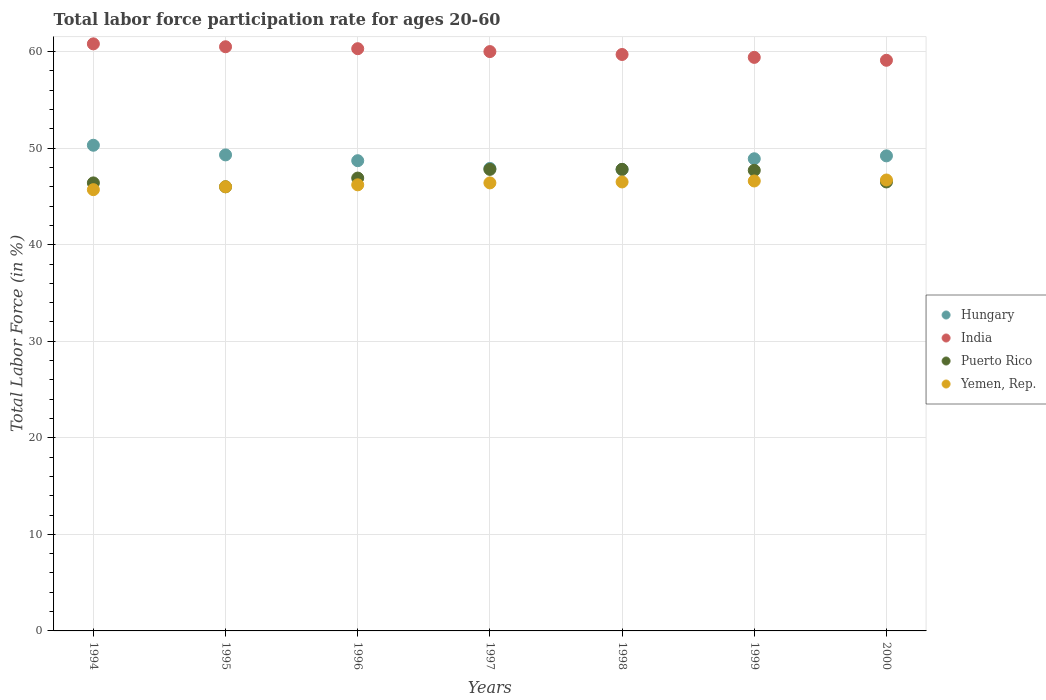Is the number of dotlines equal to the number of legend labels?
Your answer should be compact. Yes. What is the labor force participation rate in Yemen, Rep. in 1997?
Make the answer very short. 46.4. Across all years, what is the maximum labor force participation rate in India?
Keep it short and to the point. 60.8. Across all years, what is the minimum labor force participation rate in Yemen, Rep.?
Offer a terse response. 45.7. What is the total labor force participation rate in Puerto Rico in the graph?
Your answer should be very brief. 329.1. What is the difference between the labor force participation rate in Hungary in 1996 and that in 1998?
Offer a very short reply. 0.9. What is the difference between the labor force participation rate in Puerto Rico in 1998 and the labor force participation rate in Yemen, Rep. in 1994?
Provide a succinct answer. 2.1. What is the average labor force participation rate in Yemen, Rep. per year?
Provide a succinct answer. 46.3. In the year 1999, what is the difference between the labor force participation rate in India and labor force participation rate in Yemen, Rep.?
Ensure brevity in your answer.  12.8. In how many years, is the labor force participation rate in Puerto Rico greater than 46 %?
Your answer should be very brief. 6. What is the ratio of the labor force participation rate in Yemen, Rep. in 1996 to that in 2000?
Your answer should be compact. 0.99. What is the difference between the highest and the second highest labor force participation rate in India?
Offer a terse response. 0.3. What is the difference between the highest and the lowest labor force participation rate in India?
Ensure brevity in your answer.  1.7. Is the sum of the labor force participation rate in Hungary in 1995 and 1997 greater than the maximum labor force participation rate in India across all years?
Ensure brevity in your answer.  Yes. Is it the case that in every year, the sum of the labor force participation rate in Yemen, Rep. and labor force participation rate in India  is greater than the sum of labor force participation rate in Hungary and labor force participation rate in Puerto Rico?
Provide a short and direct response. Yes. Is it the case that in every year, the sum of the labor force participation rate in India and labor force participation rate in Yemen, Rep.  is greater than the labor force participation rate in Hungary?
Give a very brief answer. Yes. Does the labor force participation rate in India monotonically increase over the years?
Offer a terse response. No. Is the labor force participation rate in Puerto Rico strictly less than the labor force participation rate in Yemen, Rep. over the years?
Offer a very short reply. No. What is the difference between two consecutive major ticks on the Y-axis?
Offer a terse response. 10. Does the graph contain any zero values?
Offer a terse response. No. Does the graph contain grids?
Your answer should be very brief. Yes. What is the title of the graph?
Offer a terse response. Total labor force participation rate for ages 20-60. Does "Barbados" appear as one of the legend labels in the graph?
Offer a very short reply. No. What is the label or title of the X-axis?
Offer a very short reply. Years. What is the Total Labor Force (in %) in Hungary in 1994?
Ensure brevity in your answer.  50.3. What is the Total Labor Force (in %) of India in 1994?
Give a very brief answer. 60.8. What is the Total Labor Force (in %) in Puerto Rico in 1994?
Keep it short and to the point. 46.4. What is the Total Labor Force (in %) in Yemen, Rep. in 1994?
Keep it short and to the point. 45.7. What is the Total Labor Force (in %) of Hungary in 1995?
Your answer should be compact. 49.3. What is the Total Labor Force (in %) of India in 1995?
Your answer should be compact. 60.5. What is the Total Labor Force (in %) of Yemen, Rep. in 1995?
Provide a short and direct response. 46. What is the Total Labor Force (in %) in Hungary in 1996?
Your answer should be compact. 48.7. What is the Total Labor Force (in %) of India in 1996?
Your response must be concise. 60.3. What is the Total Labor Force (in %) of Puerto Rico in 1996?
Offer a terse response. 46.9. What is the Total Labor Force (in %) in Yemen, Rep. in 1996?
Your answer should be very brief. 46.2. What is the Total Labor Force (in %) of Hungary in 1997?
Provide a succinct answer. 47.9. What is the Total Labor Force (in %) of India in 1997?
Your response must be concise. 60. What is the Total Labor Force (in %) in Puerto Rico in 1997?
Offer a terse response. 47.8. What is the Total Labor Force (in %) in Yemen, Rep. in 1997?
Provide a succinct answer. 46.4. What is the Total Labor Force (in %) in Hungary in 1998?
Your answer should be compact. 47.8. What is the Total Labor Force (in %) in India in 1998?
Make the answer very short. 59.7. What is the Total Labor Force (in %) of Puerto Rico in 1998?
Make the answer very short. 47.8. What is the Total Labor Force (in %) of Yemen, Rep. in 1998?
Make the answer very short. 46.5. What is the Total Labor Force (in %) of Hungary in 1999?
Offer a very short reply. 48.9. What is the Total Labor Force (in %) of India in 1999?
Keep it short and to the point. 59.4. What is the Total Labor Force (in %) of Puerto Rico in 1999?
Give a very brief answer. 47.7. What is the Total Labor Force (in %) of Yemen, Rep. in 1999?
Your answer should be compact. 46.6. What is the Total Labor Force (in %) in Hungary in 2000?
Your answer should be compact. 49.2. What is the Total Labor Force (in %) of India in 2000?
Provide a short and direct response. 59.1. What is the Total Labor Force (in %) in Puerto Rico in 2000?
Ensure brevity in your answer.  46.5. What is the Total Labor Force (in %) of Yemen, Rep. in 2000?
Your answer should be very brief. 46.7. Across all years, what is the maximum Total Labor Force (in %) of Hungary?
Ensure brevity in your answer.  50.3. Across all years, what is the maximum Total Labor Force (in %) in India?
Your response must be concise. 60.8. Across all years, what is the maximum Total Labor Force (in %) of Puerto Rico?
Give a very brief answer. 47.8. Across all years, what is the maximum Total Labor Force (in %) in Yemen, Rep.?
Ensure brevity in your answer.  46.7. Across all years, what is the minimum Total Labor Force (in %) in Hungary?
Offer a very short reply. 47.8. Across all years, what is the minimum Total Labor Force (in %) of India?
Offer a terse response. 59.1. Across all years, what is the minimum Total Labor Force (in %) of Yemen, Rep.?
Give a very brief answer. 45.7. What is the total Total Labor Force (in %) of Hungary in the graph?
Offer a terse response. 342.1. What is the total Total Labor Force (in %) in India in the graph?
Your response must be concise. 419.8. What is the total Total Labor Force (in %) of Puerto Rico in the graph?
Provide a succinct answer. 329.1. What is the total Total Labor Force (in %) in Yemen, Rep. in the graph?
Your answer should be compact. 324.1. What is the difference between the Total Labor Force (in %) in Puerto Rico in 1994 and that in 1996?
Ensure brevity in your answer.  -0.5. What is the difference between the Total Labor Force (in %) of Yemen, Rep. in 1994 and that in 1996?
Your response must be concise. -0.5. What is the difference between the Total Labor Force (in %) of India in 1994 and that in 1997?
Ensure brevity in your answer.  0.8. What is the difference between the Total Labor Force (in %) of India in 1994 and that in 1998?
Your response must be concise. 1.1. What is the difference between the Total Labor Force (in %) of Puerto Rico in 1994 and that in 1999?
Ensure brevity in your answer.  -1.3. What is the difference between the Total Labor Force (in %) in Hungary in 1994 and that in 2000?
Offer a very short reply. 1.1. What is the difference between the Total Labor Force (in %) of India in 1994 and that in 2000?
Give a very brief answer. 1.7. What is the difference between the Total Labor Force (in %) in Yemen, Rep. in 1994 and that in 2000?
Your answer should be very brief. -1. What is the difference between the Total Labor Force (in %) in Puerto Rico in 1995 and that in 1996?
Offer a very short reply. -0.9. What is the difference between the Total Labor Force (in %) of Yemen, Rep. in 1995 and that in 1996?
Provide a succinct answer. -0.2. What is the difference between the Total Labor Force (in %) in India in 1995 and that in 1997?
Give a very brief answer. 0.5. What is the difference between the Total Labor Force (in %) of Puerto Rico in 1995 and that in 1997?
Ensure brevity in your answer.  -1.8. What is the difference between the Total Labor Force (in %) in Puerto Rico in 1995 and that in 1998?
Make the answer very short. -1.8. What is the difference between the Total Labor Force (in %) of Puerto Rico in 1995 and that in 1999?
Your answer should be very brief. -1.7. What is the difference between the Total Labor Force (in %) in Yemen, Rep. in 1995 and that in 1999?
Give a very brief answer. -0.6. What is the difference between the Total Labor Force (in %) of Hungary in 1995 and that in 2000?
Give a very brief answer. 0.1. What is the difference between the Total Labor Force (in %) in India in 1995 and that in 2000?
Your response must be concise. 1.4. What is the difference between the Total Labor Force (in %) of Puerto Rico in 1995 and that in 2000?
Ensure brevity in your answer.  -0.5. What is the difference between the Total Labor Force (in %) in India in 1996 and that in 1997?
Ensure brevity in your answer.  0.3. What is the difference between the Total Labor Force (in %) of Puerto Rico in 1996 and that in 1997?
Offer a terse response. -0.9. What is the difference between the Total Labor Force (in %) of Yemen, Rep. in 1996 and that in 1997?
Provide a succinct answer. -0.2. What is the difference between the Total Labor Force (in %) in India in 1996 and that in 1998?
Your answer should be very brief. 0.6. What is the difference between the Total Labor Force (in %) in Puerto Rico in 1996 and that in 1998?
Provide a succinct answer. -0.9. What is the difference between the Total Labor Force (in %) of India in 1996 and that in 1999?
Provide a succinct answer. 0.9. What is the difference between the Total Labor Force (in %) of Yemen, Rep. in 1996 and that in 1999?
Provide a succinct answer. -0.4. What is the difference between the Total Labor Force (in %) in Hungary in 1997 and that in 1999?
Offer a very short reply. -1. What is the difference between the Total Labor Force (in %) in India in 1997 and that in 1999?
Your response must be concise. 0.6. What is the difference between the Total Labor Force (in %) in Yemen, Rep. in 1997 and that in 1999?
Your response must be concise. -0.2. What is the difference between the Total Labor Force (in %) of Hungary in 1997 and that in 2000?
Offer a terse response. -1.3. What is the difference between the Total Labor Force (in %) of Yemen, Rep. in 1997 and that in 2000?
Offer a very short reply. -0.3. What is the difference between the Total Labor Force (in %) in Hungary in 1998 and that in 1999?
Offer a very short reply. -1.1. What is the difference between the Total Labor Force (in %) of India in 1998 and that in 1999?
Your answer should be compact. 0.3. What is the difference between the Total Labor Force (in %) of Puerto Rico in 1998 and that in 1999?
Provide a succinct answer. 0.1. What is the difference between the Total Labor Force (in %) in Yemen, Rep. in 1998 and that in 1999?
Make the answer very short. -0.1. What is the difference between the Total Labor Force (in %) of India in 1998 and that in 2000?
Offer a terse response. 0.6. What is the difference between the Total Labor Force (in %) of Yemen, Rep. in 1998 and that in 2000?
Ensure brevity in your answer.  -0.2. What is the difference between the Total Labor Force (in %) in India in 1999 and that in 2000?
Ensure brevity in your answer.  0.3. What is the difference between the Total Labor Force (in %) in Puerto Rico in 1999 and that in 2000?
Your answer should be very brief. 1.2. What is the difference between the Total Labor Force (in %) in Yemen, Rep. in 1999 and that in 2000?
Your answer should be compact. -0.1. What is the difference between the Total Labor Force (in %) of Hungary in 1994 and the Total Labor Force (in %) of Yemen, Rep. in 1995?
Your answer should be very brief. 4.3. What is the difference between the Total Labor Force (in %) in India in 1994 and the Total Labor Force (in %) in Puerto Rico in 1995?
Keep it short and to the point. 14.8. What is the difference between the Total Labor Force (in %) of India in 1994 and the Total Labor Force (in %) of Yemen, Rep. in 1995?
Provide a short and direct response. 14.8. What is the difference between the Total Labor Force (in %) of Puerto Rico in 1994 and the Total Labor Force (in %) of Yemen, Rep. in 1995?
Provide a succinct answer. 0.4. What is the difference between the Total Labor Force (in %) in Hungary in 1994 and the Total Labor Force (in %) in India in 1996?
Offer a very short reply. -10. What is the difference between the Total Labor Force (in %) in Hungary in 1994 and the Total Labor Force (in %) in Puerto Rico in 1996?
Make the answer very short. 3.4. What is the difference between the Total Labor Force (in %) in Hungary in 1994 and the Total Labor Force (in %) in Yemen, Rep. in 1996?
Provide a succinct answer. 4.1. What is the difference between the Total Labor Force (in %) of Hungary in 1994 and the Total Labor Force (in %) of Puerto Rico in 1997?
Offer a very short reply. 2.5. What is the difference between the Total Labor Force (in %) of India in 1994 and the Total Labor Force (in %) of Puerto Rico in 1997?
Offer a very short reply. 13. What is the difference between the Total Labor Force (in %) in India in 1994 and the Total Labor Force (in %) in Yemen, Rep. in 1997?
Your response must be concise. 14.4. What is the difference between the Total Labor Force (in %) of Hungary in 1994 and the Total Labor Force (in %) of India in 1998?
Offer a very short reply. -9.4. What is the difference between the Total Labor Force (in %) of Hungary in 1994 and the Total Labor Force (in %) of Puerto Rico in 1998?
Keep it short and to the point. 2.5. What is the difference between the Total Labor Force (in %) of India in 1994 and the Total Labor Force (in %) of Yemen, Rep. in 1998?
Offer a very short reply. 14.3. What is the difference between the Total Labor Force (in %) of Hungary in 1994 and the Total Labor Force (in %) of Puerto Rico in 1999?
Your response must be concise. 2.6. What is the difference between the Total Labor Force (in %) of India in 1994 and the Total Labor Force (in %) of Puerto Rico in 1999?
Provide a succinct answer. 13.1. What is the difference between the Total Labor Force (in %) of India in 1994 and the Total Labor Force (in %) of Yemen, Rep. in 1999?
Ensure brevity in your answer.  14.2. What is the difference between the Total Labor Force (in %) of Puerto Rico in 1994 and the Total Labor Force (in %) of Yemen, Rep. in 1999?
Provide a short and direct response. -0.2. What is the difference between the Total Labor Force (in %) in Hungary in 1994 and the Total Labor Force (in %) in Puerto Rico in 2000?
Give a very brief answer. 3.8. What is the difference between the Total Labor Force (in %) in India in 1994 and the Total Labor Force (in %) in Yemen, Rep. in 2000?
Provide a succinct answer. 14.1. What is the difference between the Total Labor Force (in %) in Hungary in 1995 and the Total Labor Force (in %) in Puerto Rico in 1996?
Offer a terse response. 2.4. What is the difference between the Total Labor Force (in %) in Hungary in 1995 and the Total Labor Force (in %) in Yemen, Rep. in 1996?
Make the answer very short. 3.1. What is the difference between the Total Labor Force (in %) of India in 1995 and the Total Labor Force (in %) of Yemen, Rep. in 1996?
Give a very brief answer. 14.3. What is the difference between the Total Labor Force (in %) in India in 1995 and the Total Labor Force (in %) in Puerto Rico in 1997?
Give a very brief answer. 12.7. What is the difference between the Total Labor Force (in %) of India in 1995 and the Total Labor Force (in %) of Yemen, Rep. in 1997?
Give a very brief answer. 14.1. What is the difference between the Total Labor Force (in %) in Puerto Rico in 1995 and the Total Labor Force (in %) in Yemen, Rep. in 1997?
Provide a short and direct response. -0.4. What is the difference between the Total Labor Force (in %) of Hungary in 1995 and the Total Labor Force (in %) of Yemen, Rep. in 1998?
Your answer should be very brief. 2.8. What is the difference between the Total Labor Force (in %) of India in 1995 and the Total Labor Force (in %) of Yemen, Rep. in 1998?
Provide a succinct answer. 14. What is the difference between the Total Labor Force (in %) in Puerto Rico in 1995 and the Total Labor Force (in %) in Yemen, Rep. in 1998?
Your answer should be very brief. -0.5. What is the difference between the Total Labor Force (in %) of Hungary in 1995 and the Total Labor Force (in %) of India in 1999?
Provide a succinct answer. -10.1. What is the difference between the Total Labor Force (in %) of Hungary in 1995 and the Total Labor Force (in %) of Puerto Rico in 1999?
Your answer should be very brief. 1.6. What is the difference between the Total Labor Force (in %) of Hungary in 1995 and the Total Labor Force (in %) of Yemen, Rep. in 1999?
Give a very brief answer. 2.7. What is the difference between the Total Labor Force (in %) of Hungary in 1995 and the Total Labor Force (in %) of India in 2000?
Provide a succinct answer. -9.8. What is the difference between the Total Labor Force (in %) in Hungary in 1995 and the Total Labor Force (in %) in Puerto Rico in 2000?
Provide a succinct answer. 2.8. What is the difference between the Total Labor Force (in %) in Hungary in 1995 and the Total Labor Force (in %) in Yemen, Rep. in 2000?
Your answer should be very brief. 2.6. What is the difference between the Total Labor Force (in %) in Puerto Rico in 1995 and the Total Labor Force (in %) in Yemen, Rep. in 2000?
Offer a terse response. -0.7. What is the difference between the Total Labor Force (in %) of Hungary in 1996 and the Total Labor Force (in %) of Puerto Rico in 1997?
Provide a short and direct response. 0.9. What is the difference between the Total Labor Force (in %) of Hungary in 1996 and the Total Labor Force (in %) of Yemen, Rep. in 1997?
Your answer should be very brief. 2.3. What is the difference between the Total Labor Force (in %) in Hungary in 1996 and the Total Labor Force (in %) in Puerto Rico in 1998?
Provide a short and direct response. 0.9. What is the difference between the Total Labor Force (in %) in India in 1996 and the Total Labor Force (in %) in Puerto Rico in 1998?
Your response must be concise. 12.5. What is the difference between the Total Labor Force (in %) of Puerto Rico in 1996 and the Total Labor Force (in %) of Yemen, Rep. in 1998?
Your answer should be very brief. 0.4. What is the difference between the Total Labor Force (in %) of Hungary in 1996 and the Total Labor Force (in %) of India in 1999?
Provide a succinct answer. -10.7. What is the difference between the Total Labor Force (in %) of Hungary in 1996 and the Total Labor Force (in %) of Puerto Rico in 1999?
Keep it short and to the point. 1. What is the difference between the Total Labor Force (in %) in India in 1996 and the Total Labor Force (in %) in Yemen, Rep. in 1999?
Your answer should be compact. 13.7. What is the difference between the Total Labor Force (in %) in Hungary in 1996 and the Total Labor Force (in %) in Puerto Rico in 2000?
Your response must be concise. 2.2. What is the difference between the Total Labor Force (in %) in Hungary in 1996 and the Total Labor Force (in %) in Yemen, Rep. in 2000?
Your response must be concise. 2. What is the difference between the Total Labor Force (in %) of Hungary in 1997 and the Total Labor Force (in %) of India in 1999?
Offer a terse response. -11.5. What is the difference between the Total Labor Force (in %) of Hungary in 1997 and the Total Labor Force (in %) of Puerto Rico in 1999?
Offer a terse response. 0.2. What is the difference between the Total Labor Force (in %) of Hungary in 1997 and the Total Labor Force (in %) of Yemen, Rep. in 1999?
Give a very brief answer. 1.3. What is the difference between the Total Labor Force (in %) in India in 1997 and the Total Labor Force (in %) in Yemen, Rep. in 1999?
Offer a very short reply. 13.4. What is the difference between the Total Labor Force (in %) of Puerto Rico in 1997 and the Total Labor Force (in %) of Yemen, Rep. in 1999?
Provide a short and direct response. 1.2. What is the difference between the Total Labor Force (in %) in India in 1997 and the Total Labor Force (in %) in Puerto Rico in 2000?
Provide a short and direct response. 13.5. What is the difference between the Total Labor Force (in %) of Hungary in 1998 and the Total Labor Force (in %) of Yemen, Rep. in 1999?
Keep it short and to the point. 1.2. What is the difference between the Total Labor Force (in %) in Puerto Rico in 1998 and the Total Labor Force (in %) in Yemen, Rep. in 1999?
Make the answer very short. 1.2. What is the difference between the Total Labor Force (in %) in Hungary in 1998 and the Total Labor Force (in %) in India in 2000?
Offer a terse response. -11.3. What is the difference between the Total Labor Force (in %) in Hungary in 1998 and the Total Labor Force (in %) in Puerto Rico in 2000?
Your answer should be compact. 1.3. What is the difference between the Total Labor Force (in %) in Hungary in 1998 and the Total Labor Force (in %) in Yemen, Rep. in 2000?
Offer a terse response. 1.1. What is the difference between the Total Labor Force (in %) in India in 1998 and the Total Labor Force (in %) in Yemen, Rep. in 2000?
Give a very brief answer. 13. What is the difference between the Total Labor Force (in %) of Puerto Rico in 1998 and the Total Labor Force (in %) of Yemen, Rep. in 2000?
Keep it short and to the point. 1.1. What is the difference between the Total Labor Force (in %) in Hungary in 1999 and the Total Labor Force (in %) in Puerto Rico in 2000?
Offer a terse response. 2.4. What is the difference between the Total Labor Force (in %) in India in 1999 and the Total Labor Force (in %) in Puerto Rico in 2000?
Provide a short and direct response. 12.9. What is the average Total Labor Force (in %) of Hungary per year?
Give a very brief answer. 48.87. What is the average Total Labor Force (in %) in India per year?
Offer a terse response. 59.97. What is the average Total Labor Force (in %) of Puerto Rico per year?
Offer a very short reply. 47.01. What is the average Total Labor Force (in %) of Yemen, Rep. per year?
Offer a very short reply. 46.3. In the year 1994, what is the difference between the Total Labor Force (in %) in Hungary and Total Labor Force (in %) in Yemen, Rep.?
Keep it short and to the point. 4.6. In the year 1994, what is the difference between the Total Labor Force (in %) in India and Total Labor Force (in %) in Puerto Rico?
Provide a short and direct response. 14.4. In the year 1994, what is the difference between the Total Labor Force (in %) in Puerto Rico and Total Labor Force (in %) in Yemen, Rep.?
Your answer should be compact. 0.7. In the year 1995, what is the difference between the Total Labor Force (in %) in Hungary and Total Labor Force (in %) in India?
Your answer should be very brief. -11.2. In the year 1995, what is the difference between the Total Labor Force (in %) of Hungary and Total Labor Force (in %) of Yemen, Rep.?
Provide a short and direct response. 3.3. In the year 1995, what is the difference between the Total Labor Force (in %) in India and Total Labor Force (in %) in Yemen, Rep.?
Make the answer very short. 14.5. In the year 1995, what is the difference between the Total Labor Force (in %) in Puerto Rico and Total Labor Force (in %) in Yemen, Rep.?
Provide a short and direct response. 0. In the year 1996, what is the difference between the Total Labor Force (in %) of Hungary and Total Labor Force (in %) of Yemen, Rep.?
Make the answer very short. 2.5. In the year 1996, what is the difference between the Total Labor Force (in %) of Puerto Rico and Total Labor Force (in %) of Yemen, Rep.?
Give a very brief answer. 0.7. In the year 1997, what is the difference between the Total Labor Force (in %) in Hungary and Total Labor Force (in %) in Puerto Rico?
Provide a succinct answer. 0.1. In the year 1997, what is the difference between the Total Labor Force (in %) of Hungary and Total Labor Force (in %) of Yemen, Rep.?
Your answer should be compact. 1.5. In the year 1998, what is the difference between the Total Labor Force (in %) in Hungary and Total Labor Force (in %) in Puerto Rico?
Provide a short and direct response. 0. In the year 1998, what is the difference between the Total Labor Force (in %) of Hungary and Total Labor Force (in %) of Yemen, Rep.?
Provide a succinct answer. 1.3. In the year 1998, what is the difference between the Total Labor Force (in %) of India and Total Labor Force (in %) of Yemen, Rep.?
Keep it short and to the point. 13.2. In the year 1998, what is the difference between the Total Labor Force (in %) in Puerto Rico and Total Labor Force (in %) in Yemen, Rep.?
Make the answer very short. 1.3. In the year 1999, what is the difference between the Total Labor Force (in %) of Hungary and Total Labor Force (in %) of India?
Give a very brief answer. -10.5. In the year 1999, what is the difference between the Total Labor Force (in %) in Hungary and Total Labor Force (in %) in Yemen, Rep.?
Provide a succinct answer. 2.3. In the year 1999, what is the difference between the Total Labor Force (in %) in India and Total Labor Force (in %) in Puerto Rico?
Your answer should be compact. 11.7. In the year 2000, what is the difference between the Total Labor Force (in %) in Hungary and Total Labor Force (in %) in India?
Ensure brevity in your answer.  -9.9. In the year 2000, what is the difference between the Total Labor Force (in %) of Hungary and Total Labor Force (in %) of Puerto Rico?
Provide a succinct answer. 2.7. In the year 2000, what is the difference between the Total Labor Force (in %) of Hungary and Total Labor Force (in %) of Yemen, Rep.?
Offer a very short reply. 2.5. In the year 2000, what is the difference between the Total Labor Force (in %) in India and Total Labor Force (in %) in Puerto Rico?
Your answer should be very brief. 12.6. In the year 2000, what is the difference between the Total Labor Force (in %) in Puerto Rico and Total Labor Force (in %) in Yemen, Rep.?
Provide a short and direct response. -0.2. What is the ratio of the Total Labor Force (in %) of Hungary in 1994 to that in 1995?
Provide a short and direct response. 1.02. What is the ratio of the Total Labor Force (in %) in India in 1994 to that in 1995?
Provide a succinct answer. 1. What is the ratio of the Total Labor Force (in %) of Puerto Rico in 1994 to that in 1995?
Ensure brevity in your answer.  1.01. What is the ratio of the Total Labor Force (in %) in Hungary in 1994 to that in 1996?
Offer a terse response. 1.03. What is the ratio of the Total Labor Force (in %) of India in 1994 to that in 1996?
Offer a very short reply. 1.01. What is the ratio of the Total Labor Force (in %) in Puerto Rico in 1994 to that in 1996?
Keep it short and to the point. 0.99. What is the ratio of the Total Labor Force (in %) of Yemen, Rep. in 1994 to that in 1996?
Offer a terse response. 0.99. What is the ratio of the Total Labor Force (in %) in Hungary in 1994 to that in 1997?
Provide a short and direct response. 1.05. What is the ratio of the Total Labor Force (in %) in India in 1994 to that in 1997?
Keep it short and to the point. 1.01. What is the ratio of the Total Labor Force (in %) in Puerto Rico in 1994 to that in 1997?
Offer a very short reply. 0.97. What is the ratio of the Total Labor Force (in %) of Yemen, Rep. in 1994 to that in 1997?
Keep it short and to the point. 0.98. What is the ratio of the Total Labor Force (in %) in Hungary in 1994 to that in 1998?
Ensure brevity in your answer.  1.05. What is the ratio of the Total Labor Force (in %) in India in 1994 to that in 1998?
Offer a very short reply. 1.02. What is the ratio of the Total Labor Force (in %) of Puerto Rico in 1994 to that in 1998?
Provide a short and direct response. 0.97. What is the ratio of the Total Labor Force (in %) of Yemen, Rep. in 1994 to that in 1998?
Provide a short and direct response. 0.98. What is the ratio of the Total Labor Force (in %) of Hungary in 1994 to that in 1999?
Your answer should be very brief. 1.03. What is the ratio of the Total Labor Force (in %) in India in 1994 to that in 1999?
Offer a very short reply. 1.02. What is the ratio of the Total Labor Force (in %) in Puerto Rico in 1994 to that in 1999?
Provide a short and direct response. 0.97. What is the ratio of the Total Labor Force (in %) in Yemen, Rep. in 1994 to that in 1999?
Provide a short and direct response. 0.98. What is the ratio of the Total Labor Force (in %) of Hungary in 1994 to that in 2000?
Your answer should be very brief. 1.02. What is the ratio of the Total Labor Force (in %) of India in 1994 to that in 2000?
Your answer should be compact. 1.03. What is the ratio of the Total Labor Force (in %) in Puerto Rico in 1994 to that in 2000?
Keep it short and to the point. 1. What is the ratio of the Total Labor Force (in %) in Yemen, Rep. in 1994 to that in 2000?
Make the answer very short. 0.98. What is the ratio of the Total Labor Force (in %) of Hungary in 1995 to that in 1996?
Your answer should be compact. 1.01. What is the ratio of the Total Labor Force (in %) in Puerto Rico in 1995 to that in 1996?
Give a very brief answer. 0.98. What is the ratio of the Total Labor Force (in %) of Yemen, Rep. in 1995 to that in 1996?
Make the answer very short. 1. What is the ratio of the Total Labor Force (in %) in Hungary in 1995 to that in 1997?
Offer a terse response. 1.03. What is the ratio of the Total Labor Force (in %) in India in 1995 to that in 1997?
Your response must be concise. 1.01. What is the ratio of the Total Labor Force (in %) in Puerto Rico in 1995 to that in 1997?
Give a very brief answer. 0.96. What is the ratio of the Total Labor Force (in %) of Hungary in 1995 to that in 1998?
Provide a short and direct response. 1.03. What is the ratio of the Total Labor Force (in %) in India in 1995 to that in 1998?
Your answer should be compact. 1.01. What is the ratio of the Total Labor Force (in %) in Puerto Rico in 1995 to that in 1998?
Provide a short and direct response. 0.96. What is the ratio of the Total Labor Force (in %) in Hungary in 1995 to that in 1999?
Provide a succinct answer. 1.01. What is the ratio of the Total Labor Force (in %) of India in 1995 to that in 1999?
Offer a terse response. 1.02. What is the ratio of the Total Labor Force (in %) of Puerto Rico in 1995 to that in 1999?
Ensure brevity in your answer.  0.96. What is the ratio of the Total Labor Force (in %) in Yemen, Rep. in 1995 to that in 1999?
Offer a terse response. 0.99. What is the ratio of the Total Labor Force (in %) in Hungary in 1995 to that in 2000?
Offer a terse response. 1. What is the ratio of the Total Labor Force (in %) of India in 1995 to that in 2000?
Offer a very short reply. 1.02. What is the ratio of the Total Labor Force (in %) of Yemen, Rep. in 1995 to that in 2000?
Make the answer very short. 0.98. What is the ratio of the Total Labor Force (in %) of Hungary in 1996 to that in 1997?
Offer a very short reply. 1.02. What is the ratio of the Total Labor Force (in %) of India in 1996 to that in 1997?
Your response must be concise. 1. What is the ratio of the Total Labor Force (in %) in Puerto Rico in 1996 to that in 1997?
Your answer should be very brief. 0.98. What is the ratio of the Total Labor Force (in %) in Yemen, Rep. in 1996 to that in 1997?
Keep it short and to the point. 1. What is the ratio of the Total Labor Force (in %) in Hungary in 1996 to that in 1998?
Your answer should be compact. 1.02. What is the ratio of the Total Labor Force (in %) of India in 1996 to that in 1998?
Make the answer very short. 1.01. What is the ratio of the Total Labor Force (in %) in Puerto Rico in 1996 to that in 1998?
Your answer should be compact. 0.98. What is the ratio of the Total Labor Force (in %) of Hungary in 1996 to that in 1999?
Your response must be concise. 1. What is the ratio of the Total Labor Force (in %) in India in 1996 to that in 1999?
Keep it short and to the point. 1.02. What is the ratio of the Total Labor Force (in %) of Puerto Rico in 1996 to that in 1999?
Keep it short and to the point. 0.98. What is the ratio of the Total Labor Force (in %) in Yemen, Rep. in 1996 to that in 1999?
Provide a succinct answer. 0.99. What is the ratio of the Total Labor Force (in %) of India in 1996 to that in 2000?
Offer a terse response. 1.02. What is the ratio of the Total Labor Force (in %) in Puerto Rico in 1996 to that in 2000?
Give a very brief answer. 1.01. What is the ratio of the Total Labor Force (in %) of Yemen, Rep. in 1996 to that in 2000?
Give a very brief answer. 0.99. What is the ratio of the Total Labor Force (in %) of Hungary in 1997 to that in 1998?
Provide a succinct answer. 1. What is the ratio of the Total Labor Force (in %) of India in 1997 to that in 1998?
Your answer should be compact. 1. What is the ratio of the Total Labor Force (in %) in Hungary in 1997 to that in 1999?
Provide a succinct answer. 0.98. What is the ratio of the Total Labor Force (in %) in India in 1997 to that in 1999?
Give a very brief answer. 1.01. What is the ratio of the Total Labor Force (in %) in Puerto Rico in 1997 to that in 1999?
Your answer should be very brief. 1. What is the ratio of the Total Labor Force (in %) in Yemen, Rep. in 1997 to that in 1999?
Your response must be concise. 1. What is the ratio of the Total Labor Force (in %) in Hungary in 1997 to that in 2000?
Offer a terse response. 0.97. What is the ratio of the Total Labor Force (in %) in India in 1997 to that in 2000?
Offer a very short reply. 1.02. What is the ratio of the Total Labor Force (in %) in Puerto Rico in 1997 to that in 2000?
Offer a terse response. 1.03. What is the ratio of the Total Labor Force (in %) in Hungary in 1998 to that in 1999?
Offer a very short reply. 0.98. What is the ratio of the Total Labor Force (in %) in India in 1998 to that in 1999?
Provide a short and direct response. 1.01. What is the ratio of the Total Labor Force (in %) of Puerto Rico in 1998 to that in 1999?
Give a very brief answer. 1. What is the ratio of the Total Labor Force (in %) of Yemen, Rep. in 1998 to that in 1999?
Make the answer very short. 1. What is the ratio of the Total Labor Force (in %) of Hungary in 1998 to that in 2000?
Offer a terse response. 0.97. What is the ratio of the Total Labor Force (in %) in India in 1998 to that in 2000?
Your answer should be very brief. 1.01. What is the ratio of the Total Labor Force (in %) in Puerto Rico in 1998 to that in 2000?
Give a very brief answer. 1.03. What is the ratio of the Total Labor Force (in %) of Yemen, Rep. in 1998 to that in 2000?
Ensure brevity in your answer.  1. What is the ratio of the Total Labor Force (in %) in Puerto Rico in 1999 to that in 2000?
Make the answer very short. 1.03. What is the difference between the highest and the second highest Total Labor Force (in %) of Hungary?
Make the answer very short. 1. What is the difference between the highest and the second highest Total Labor Force (in %) of Puerto Rico?
Provide a short and direct response. 0. What is the difference between the highest and the lowest Total Labor Force (in %) in Yemen, Rep.?
Make the answer very short. 1. 